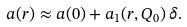Convert formula to latex. <formula><loc_0><loc_0><loc_500><loc_500>a ( r ) \approx a ( 0 ) + a _ { 1 } ( r , Q _ { 0 } ) \, \delta .</formula> 